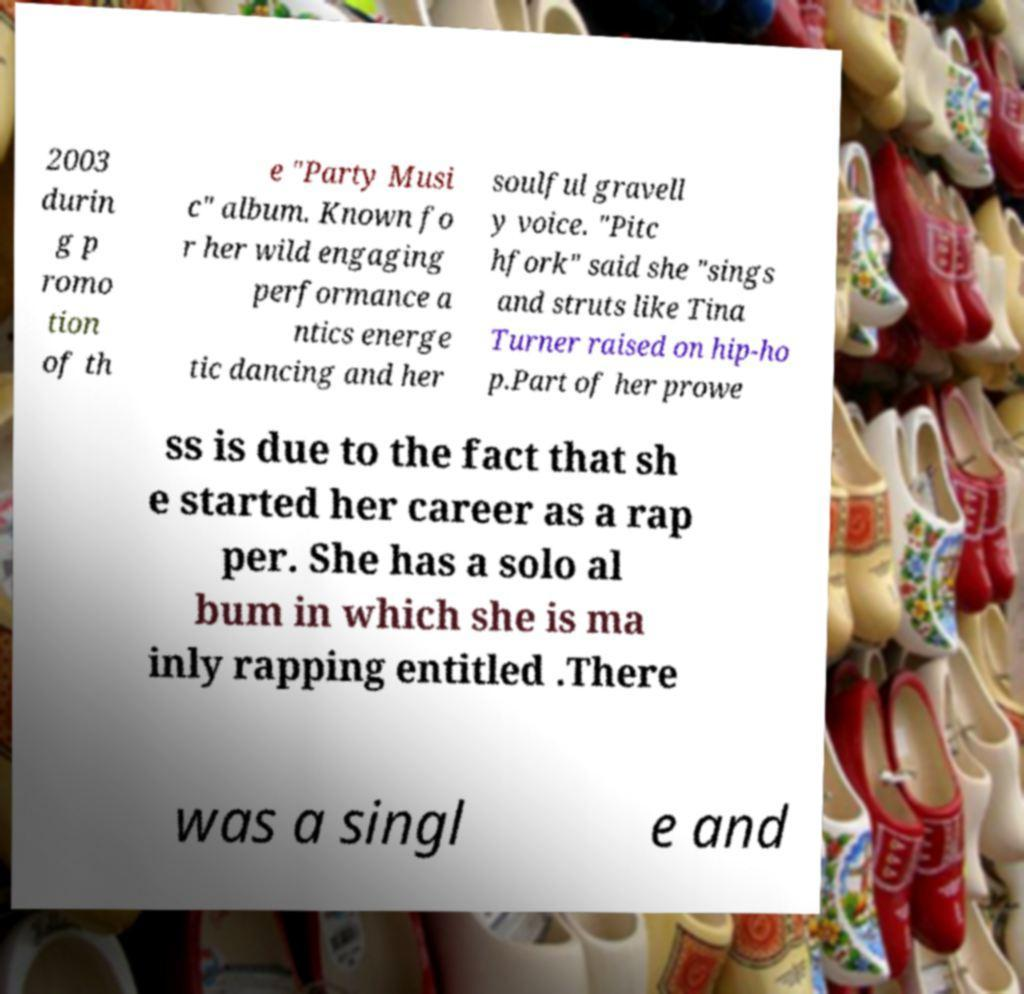Could you assist in decoding the text presented in this image and type it out clearly? 2003 durin g p romo tion of th e "Party Musi c" album. Known fo r her wild engaging performance a ntics energe tic dancing and her soulful gravell y voice. "Pitc hfork" said she "sings and struts like Tina Turner raised on hip-ho p.Part of her prowe ss is due to the fact that sh e started her career as a rap per. She has a solo al bum in which she is ma inly rapping entitled .There was a singl e and 